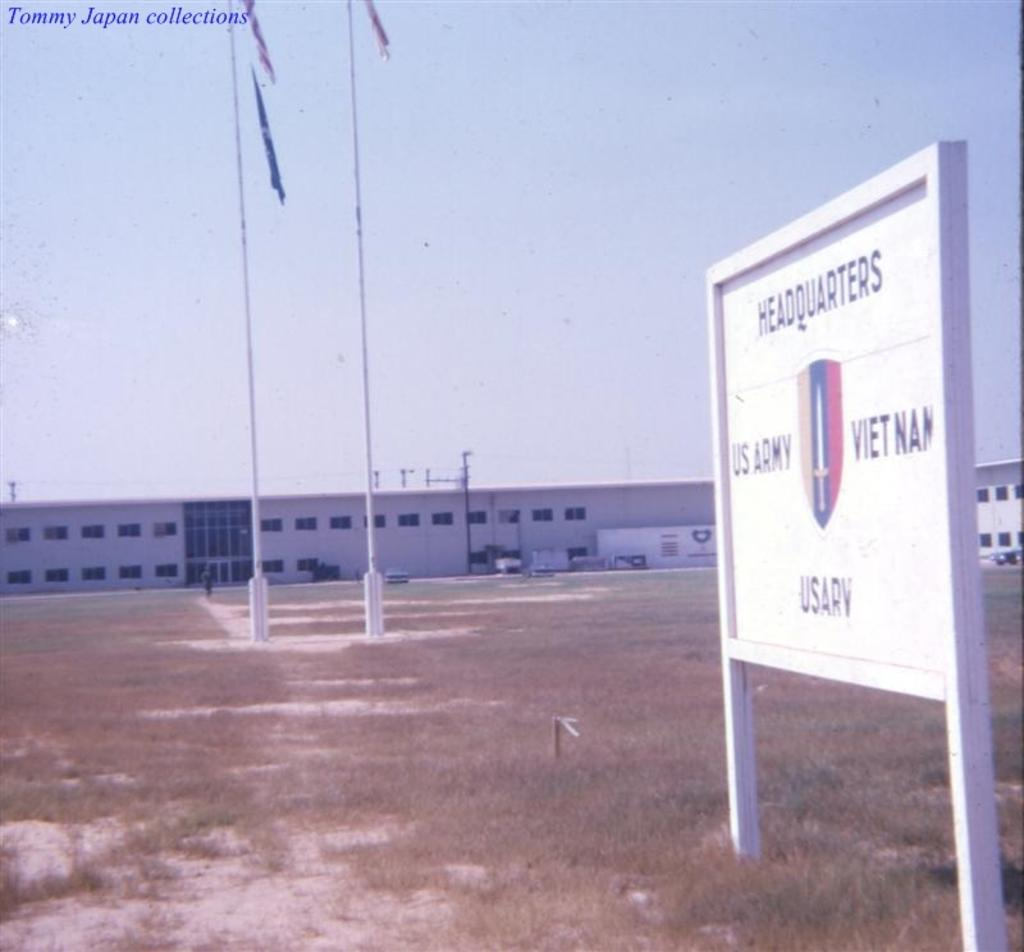<image>
Summarize the visual content of the image. Tommy Japan took a picture of the US Army Vietnam Headquarters 